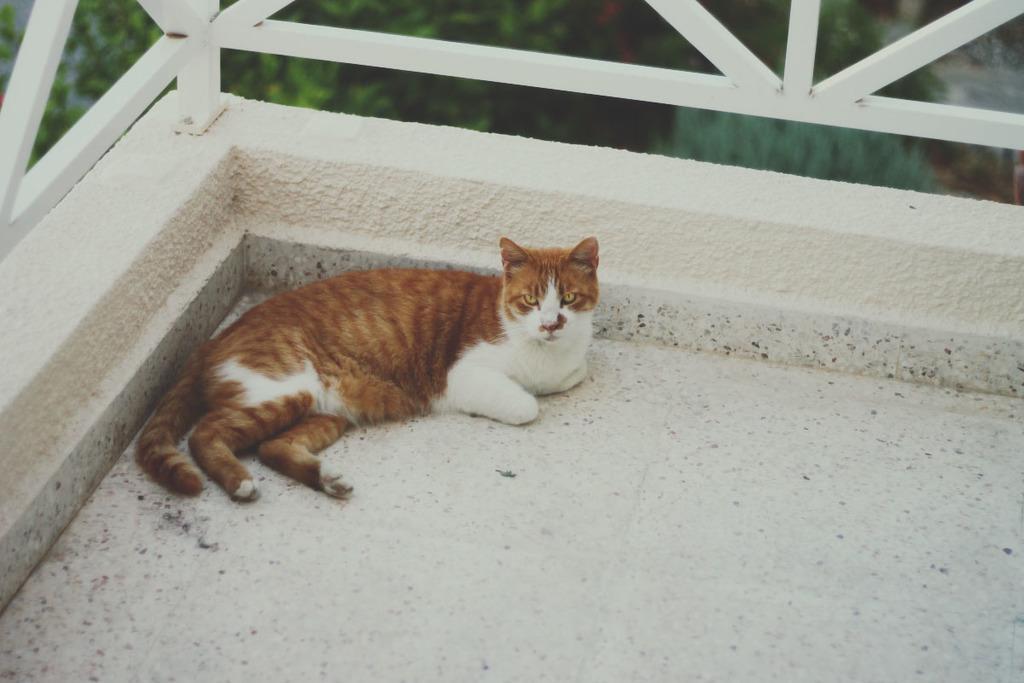Could you give a brief overview of what you see in this image? In this picture I can see a cat on the floor and I can see metal fence and a tree in the background. 